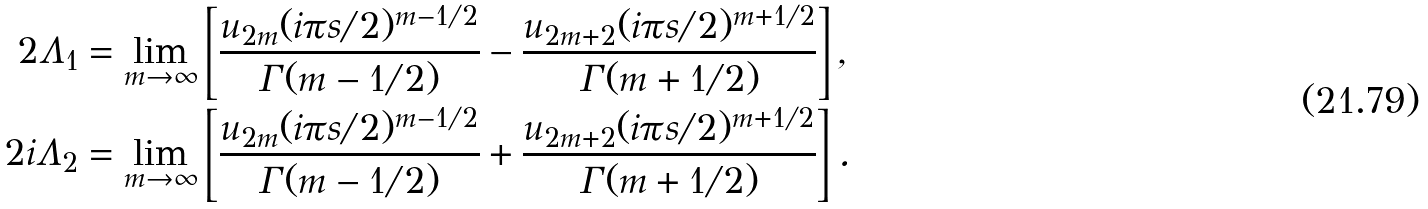<formula> <loc_0><loc_0><loc_500><loc_500>2 \Lambda _ { 1 } & = \lim _ { m \rightarrow \infty } \left [ \frac { u _ { 2 m } ( i \pi s / 2 ) ^ { m - 1 / 2 } } { \Gamma ( m - 1 / 2 ) } - \frac { u _ { 2 m + 2 } ( i \pi s / 2 ) ^ { m + 1 / 2 } } { \Gamma ( m + 1 / 2 ) } \right ] , \\ 2 i \Lambda _ { 2 } & = \lim _ { m \rightarrow \infty } \left [ \frac { u _ { 2 m } ( i \pi s / 2 ) ^ { m - 1 / 2 } } { \Gamma ( m - 1 / 2 ) } + \frac { u _ { 2 m + 2 } ( i \pi s / 2 ) ^ { m + 1 / 2 } } { \Gamma ( m + 1 / 2 ) } \right ] .</formula> 